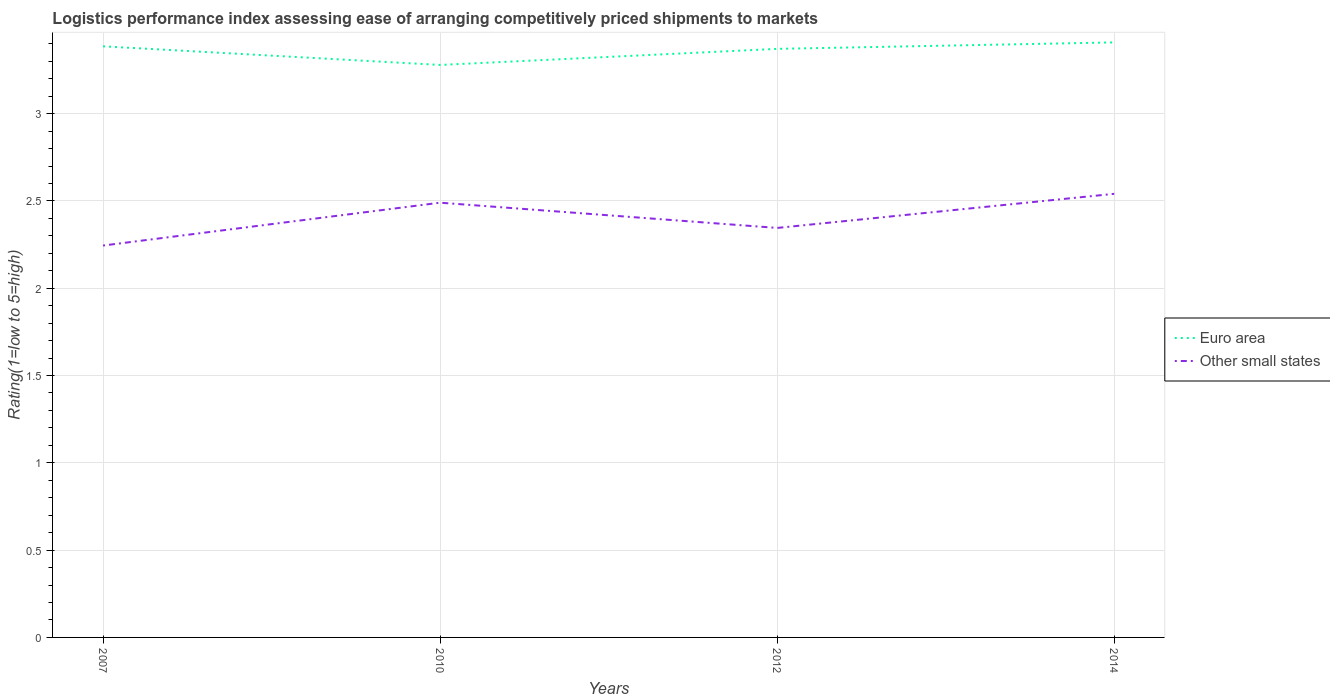Does the line corresponding to Euro area intersect with the line corresponding to Other small states?
Keep it short and to the point. No. Is the number of lines equal to the number of legend labels?
Your answer should be very brief. Yes. Across all years, what is the maximum Logistic performance index in Euro area?
Give a very brief answer. 3.28. In which year was the Logistic performance index in Euro area maximum?
Make the answer very short. 2010. What is the total Logistic performance index in Other small states in the graph?
Your answer should be very brief. 0.14. What is the difference between the highest and the second highest Logistic performance index in Other small states?
Your answer should be very brief. 0.3. Is the Logistic performance index in Other small states strictly greater than the Logistic performance index in Euro area over the years?
Provide a succinct answer. Yes. How many years are there in the graph?
Your answer should be compact. 4. Does the graph contain any zero values?
Your response must be concise. No. Where does the legend appear in the graph?
Your answer should be compact. Center right. How are the legend labels stacked?
Your answer should be very brief. Vertical. What is the title of the graph?
Ensure brevity in your answer.  Logistics performance index assessing ease of arranging competitively priced shipments to markets. What is the label or title of the X-axis?
Provide a succinct answer. Years. What is the label or title of the Y-axis?
Provide a succinct answer. Rating(1=low to 5=high). What is the Rating(1=low to 5=high) of Euro area in 2007?
Your response must be concise. 3.39. What is the Rating(1=low to 5=high) of Other small states in 2007?
Your response must be concise. 2.24. What is the Rating(1=low to 5=high) of Euro area in 2010?
Keep it short and to the point. 3.28. What is the Rating(1=low to 5=high) of Other small states in 2010?
Your response must be concise. 2.49. What is the Rating(1=low to 5=high) of Euro area in 2012?
Give a very brief answer. 3.37. What is the Rating(1=low to 5=high) of Other small states in 2012?
Offer a terse response. 2.35. What is the Rating(1=low to 5=high) in Euro area in 2014?
Your response must be concise. 3.41. What is the Rating(1=low to 5=high) of Other small states in 2014?
Provide a short and direct response. 2.54. Across all years, what is the maximum Rating(1=low to 5=high) in Euro area?
Offer a terse response. 3.41. Across all years, what is the maximum Rating(1=low to 5=high) in Other small states?
Ensure brevity in your answer.  2.54. Across all years, what is the minimum Rating(1=low to 5=high) of Euro area?
Give a very brief answer. 3.28. Across all years, what is the minimum Rating(1=low to 5=high) in Other small states?
Offer a terse response. 2.24. What is the total Rating(1=low to 5=high) of Euro area in the graph?
Provide a short and direct response. 13.44. What is the total Rating(1=low to 5=high) in Other small states in the graph?
Your answer should be very brief. 9.62. What is the difference between the Rating(1=low to 5=high) in Euro area in 2007 and that in 2010?
Offer a terse response. 0.11. What is the difference between the Rating(1=low to 5=high) in Other small states in 2007 and that in 2010?
Keep it short and to the point. -0.25. What is the difference between the Rating(1=low to 5=high) in Euro area in 2007 and that in 2012?
Offer a terse response. 0.01. What is the difference between the Rating(1=low to 5=high) in Other small states in 2007 and that in 2012?
Give a very brief answer. -0.1. What is the difference between the Rating(1=low to 5=high) of Euro area in 2007 and that in 2014?
Make the answer very short. -0.02. What is the difference between the Rating(1=low to 5=high) of Other small states in 2007 and that in 2014?
Offer a terse response. -0.3. What is the difference between the Rating(1=low to 5=high) of Euro area in 2010 and that in 2012?
Your answer should be compact. -0.09. What is the difference between the Rating(1=low to 5=high) in Other small states in 2010 and that in 2012?
Keep it short and to the point. 0.14. What is the difference between the Rating(1=low to 5=high) of Euro area in 2010 and that in 2014?
Offer a terse response. -0.13. What is the difference between the Rating(1=low to 5=high) in Other small states in 2010 and that in 2014?
Your answer should be very brief. -0.05. What is the difference between the Rating(1=low to 5=high) of Euro area in 2012 and that in 2014?
Your answer should be compact. -0.04. What is the difference between the Rating(1=low to 5=high) in Other small states in 2012 and that in 2014?
Give a very brief answer. -0.2. What is the difference between the Rating(1=low to 5=high) in Euro area in 2007 and the Rating(1=low to 5=high) in Other small states in 2010?
Your answer should be compact. 0.9. What is the difference between the Rating(1=low to 5=high) in Euro area in 2007 and the Rating(1=low to 5=high) in Other small states in 2012?
Provide a succinct answer. 1.04. What is the difference between the Rating(1=low to 5=high) of Euro area in 2007 and the Rating(1=low to 5=high) of Other small states in 2014?
Provide a succinct answer. 0.84. What is the difference between the Rating(1=low to 5=high) of Euro area in 2010 and the Rating(1=low to 5=high) of Other small states in 2012?
Ensure brevity in your answer.  0.93. What is the difference between the Rating(1=low to 5=high) in Euro area in 2010 and the Rating(1=low to 5=high) in Other small states in 2014?
Make the answer very short. 0.74. What is the difference between the Rating(1=low to 5=high) of Euro area in 2012 and the Rating(1=low to 5=high) of Other small states in 2014?
Offer a terse response. 0.83. What is the average Rating(1=low to 5=high) of Euro area per year?
Provide a succinct answer. 3.36. What is the average Rating(1=low to 5=high) of Other small states per year?
Your answer should be very brief. 2.41. In the year 2007, what is the difference between the Rating(1=low to 5=high) of Euro area and Rating(1=low to 5=high) of Other small states?
Keep it short and to the point. 1.14. In the year 2010, what is the difference between the Rating(1=low to 5=high) of Euro area and Rating(1=low to 5=high) of Other small states?
Your answer should be compact. 0.79. In the year 2012, what is the difference between the Rating(1=low to 5=high) of Euro area and Rating(1=low to 5=high) of Other small states?
Keep it short and to the point. 1.03. In the year 2014, what is the difference between the Rating(1=low to 5=high) of Euro area and Rating(1=low to 5=high) of Other small states?
Your answer should be compact. 0.87. What is the ratio of the Rating(1=low to 5=high) of Euro area in 2007 to that in 2010?
Ensure brevity in your answer.  1.03. What is the ratio of the Rating(1=low to 5=high) of Other small states in 2007 to that in 2010?
Your answer should be very brief. 0.9. What is the ratio of the Rating(1=low to 5=high) of Euro area in 2007 to that in 2012?
Offer a very short reply. 1. What is the ratio of the Rating(1=low to 5=high) of Other small states in 2007 to that in 2014?
Your answer should be compact. 0.88. What is the ratio of the Rating(1=low to 5=high) of Euro area in 2010 to that in 2012?
Provide a succinct answer. 0.97. What is the ratio of the Rating(1=low to 5=high) in Other small states in 2010 to that in 2012?
Ensure brevity in your answer.  1.06. What is the ratio of the Rating(1=low to 5=high) in Euro area in 2010 to that in 2014?
Your response must be concise. 0.96. What is the ratio of the Rating(1=low to 5=high) of Other small states in 2010 to that in 2014?
Offer a terse response. 0.98. What is the ratio of the Rating(1=low to 5=high) in Euro area in 2012 to that in 2014?
Ensure brevity in your answer.  0.99. What is the difference between the highest and the second highest Rating(1=low to 5=high) of Euro area?
Offer a very short reply. 0.02. What is the difference between the highest and the second highest Rating(1=low to 5=high) in Other small states?
Provide a short and direct response. 0.05. What is the difference between the highest and the lowest Rating(1=low to 5=high) of Euro area?
Your answer should be compact. 0.13. What is the difference between the highest and the lowest Rating(1=low to 5=high) in Other small states?
Give a very brief answer. 0.3. 